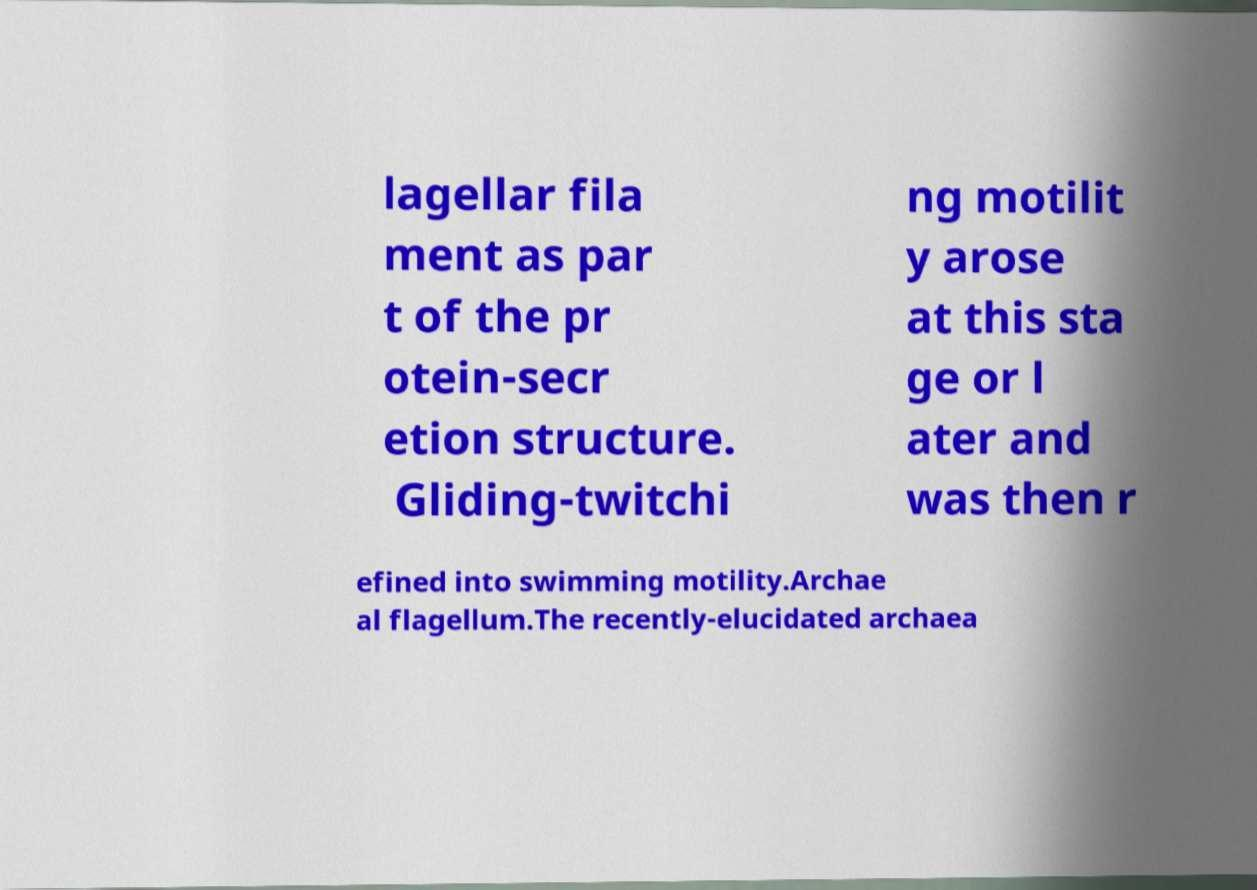I need the written content from this picture converted into text. Can you do that? lagellar fila ment as par t of the pr otein-secr etion structure. Gliding-twitchi ng motilit y arose at this sta ge or l ater and was then r efined into swimming motility.Archae al flagellum.The recently-elucidated archaea 